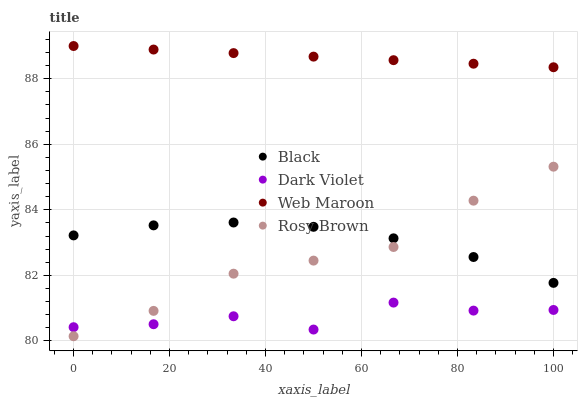Does Dark Violet have the minimum area under the curve?
Answer yes or no. Yes. Does Web Maroon have the maximum area under the curve?
Answer yes or no. Yes. Does Rosy Brown have the minimum area under the curve?
Answer yes or no. No. Does Rosy Brown have the maximum area under the curve?
Answer yes or no. No. Is Web Maroon the smoothest?
Answer yes or no. Yes. Is Dark Violet the roughest?
Answer yes or no. Yes. Is Rosy Brown the smoothest?
Answer yes or no. No. Is Rosy Brown the roughest?
Answer yes or no. No. Does Rosy Brown have the lowest value?
Answer yes or no. Yes. Does Black have the lowest value?
Answer yes or no. No. Does Web Maroon have the highest value?
Answer yes or no. Yes. Does Rosy Brown have the highest value?
Answer yes or no. No. Is Rosy Brown less than Web Maroon?
Answer yes or no. Yes. Is Black greater than Dark Violet?
Answer yes or no. Yes. Does Black intersect Rosy Brown?
Answer yes or no. Yes. Is Black less than Rosy Brown?
Answer yes or no. No. Is Black greater than Rosy Brown?
Answer yes or no. No. Does Rosy Brown intersect Web Maroon?
Answer yes or no. No. 